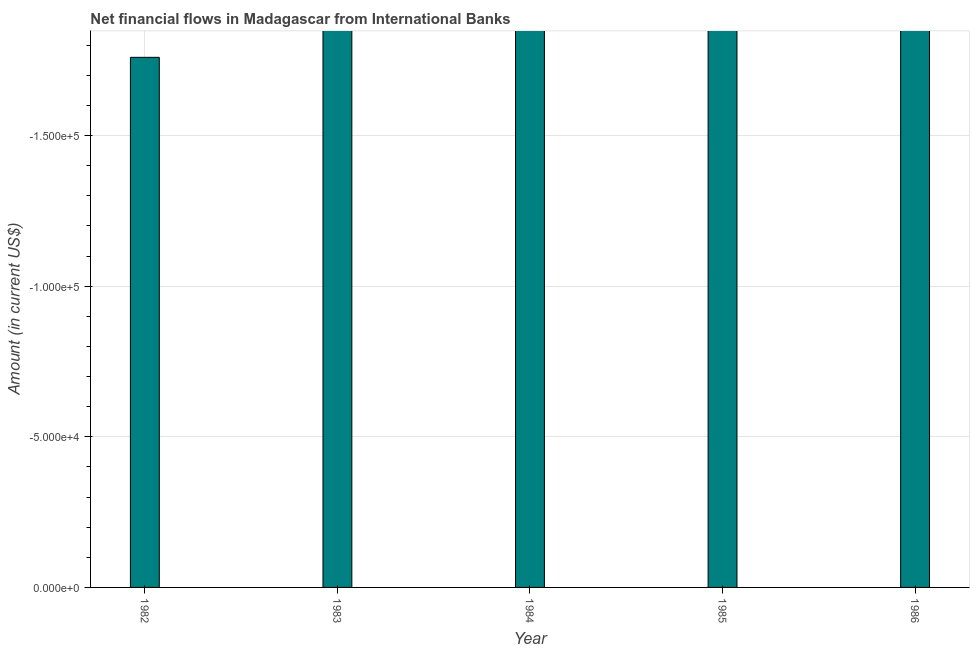Does the graph contain grids?
Your response must be concise. Yes. What is the title of the graph?
Your response must be concise. Net financial flows in Madagascar from International Banks. What is the label or title of the Y-axis?
Keep it short and to the point. Amount (in current US$). Across all years, what is the minimum net financial flows from ibrd?
Provide a succinct answer. 0. In how many years, is the net financial flows from ibrd greater than -60000 US$?
Keep it short and to the point. 0. How many bars are there?
Your response must be concise. 0. What is the difference between two consecutive major ticks on the Y-axis?
Provide a short and direct response. 5.00e+04. Are the values on the major ticks of Y-axis written in scientific E-notation?
Ensure brevity in your answer.  Yes. What is the Amount (in current US$) in 1983?
Your response must be concise. 0. 